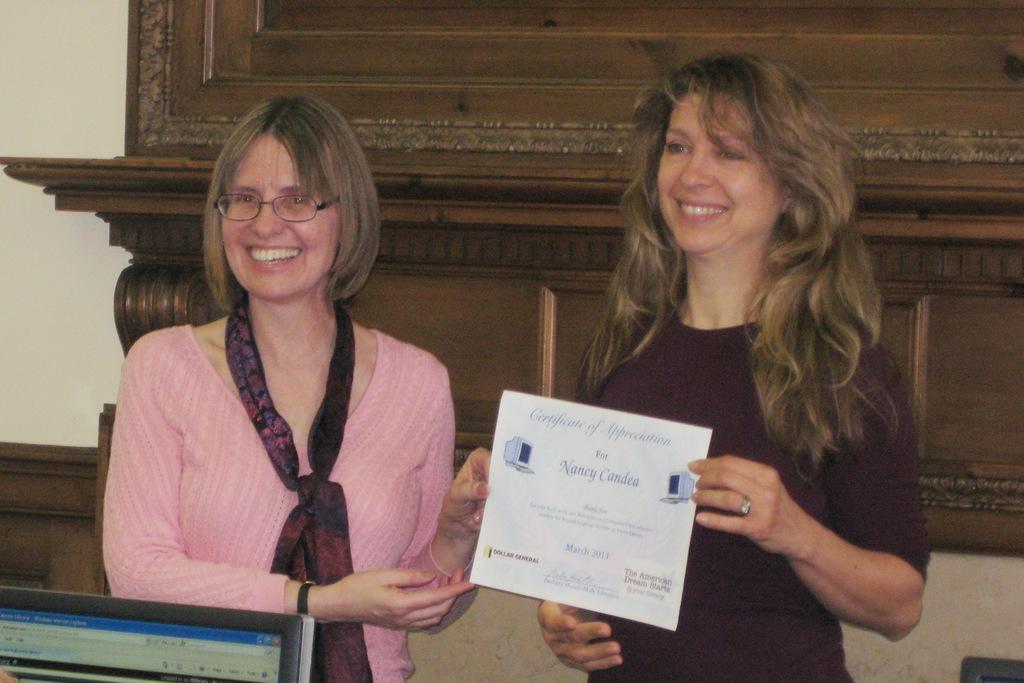What kind of certificate is this?
Give a very brief answer. Unanswerable. What is the first letter of her first name?
Your answer should be compact. N. 